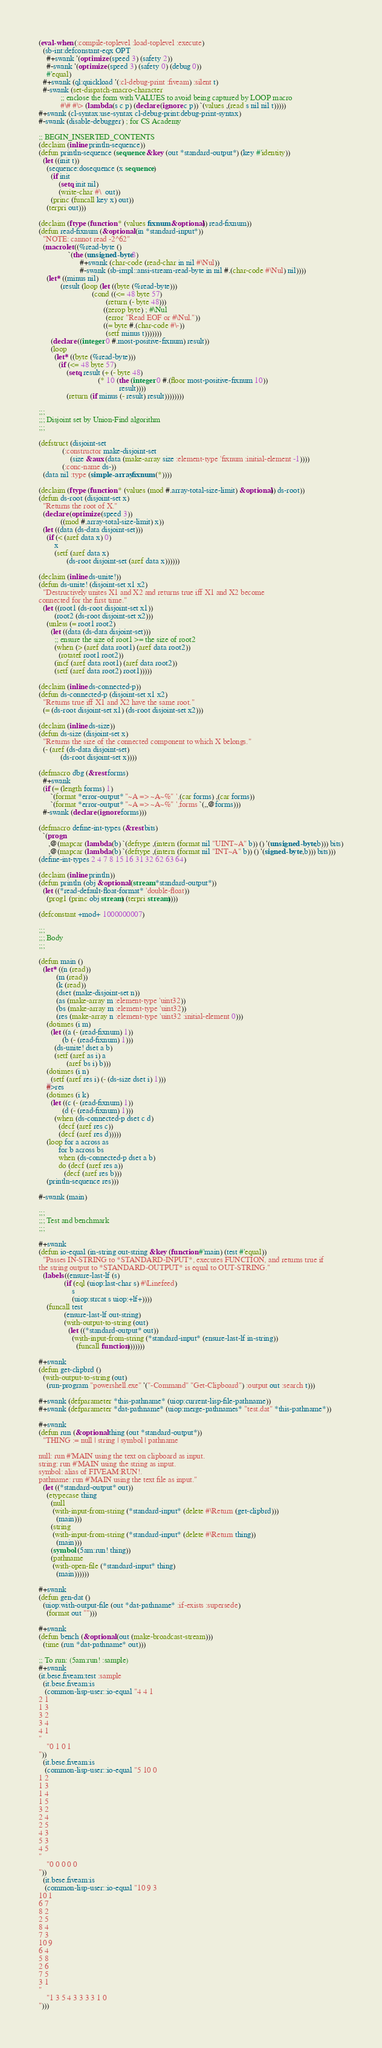<code> <loc_0><loc_0><loc_500><loc_500><_Lisp_>(eval-when (:compile-toplevel :load-toplevel :execute)
  (sb-int:defconstant-eqx OPT
    #+swank '(optimize (speed 3) (safety 2))
    #-swank '(optimize (speed 3) (safety 0) (debug 0))
    #'equal)
  #+swank (ql:quickload '(:cl-debug-print :fiveam) :silent t)
  #-swank (set-dispatch-macro-character
           ;; enclose the form with VALUES to avoid being captured by LOOP macro
           #\# #\> (lambda (s c p) (declare (ignore c p)) `(values ,(read s nil nil t)))))
#+swank (cl-syntax:use-syntax cl-debug-print:debug-print-syntax)
#-swank (disable-debugger) ; for CS Academy

;; BEGIN_INSERTED_CONTENTS
(declaim (inline println-sequence))
(defun println-sequence (sequence &key (out *standard-output*) (key #'identity))
  (let ((init t))
    (sequence:dosequence (x sequence)
      (if init
          (setq init nil)
          (write-char #\  out))
      (princ (funcall key x) out))
    (terpri out)))

(declaim (ftype (function * (values fixnum &optional)) read-fixnum))
(defun read-fixnum (&optional (in *standard-input*))
  "NOTE: cannot read -2^62"
  (macrolet ((%read-byte ()
               `(the (unsigned-byte 8)
                     #+swank (char-code (read-char in nil #\Nul))
                     #-swank (sb-impl::ansi-stream-read-byte in nil #.(char-code #\Nul) nil))))
    (let* ((minus nil)
           (result (loop (let ((byte (%read-byte)))
                           (cond ((<= 48 byte 57)
                                  (return (- byte 48)))
                                 ((zerop byte) ; #\Nul
                                  (error "Read EOF or #\Nul."))
                                 ((= byte #.(char-code #\-))
                                  (setf minus t)))))))
      (declare ((integer 0 #.most-positive-fixnum) result))
      (loop
        (let* ((byte (%read-byte)))
          (if (<= 48 byte 57)
              (setq result (+ (- byte 48)
                              (* 10 (the (integer 0 #.(floor most-positive-fixnum 10))
                                         result))))
              (return (if minus (- result) result))))))))

;;;
;;; Disjoint set by Union-Find algorithm
;;;

(defstruct (disjoint-set
            (:constructor make-disjoint-set
                (size &aux (data (make-array size :element-type 'fixnum :initial-element -1))))
            (:conc-name ds-))
  (data nil :type (simple-array fixnum (*))))

(declaim (ftype (function * (values (mod #.array-total-size-limit) &optional)) ds-root))
(defun ds-root (disjoint-set x)
  "Returns the root of X."
  (declare (optimize (speed 3))
           ((mod #.array-total-size-limit) x))
  (let ((data (ds-data disjoint-set)))
    (if (< (aref data x) 0)
        x
        (setf (aref data x)
              (ds-root disjoint-set (aref data x))))))

(declaim (inline ds-unite!))
(defun ds-unite! (disjoint-set x1 x2)
  "Destructively unites X1 and X2 and returns true iff X1 and X2 become
connected for the first time."
  (let ((root1 (ds-root disjoint-set x1))
        (root2 (ds-root disjoint-set x2)))
    (unless (= root1 root2)
      (let ((data (ds-data disjoint-set)))
        ;; ensure the size of root1 >= the size of root2
        (when (> (aref data root1) (aref data root2))
          (rotatef root1 root2))
        (incf (aref data root1) (aref data root2))
        (setf (aref data root2) root1)))))

(declaim (inline ds-connected-p))
(defun ds-connected-p (disjoint-set x1 x2)
  "Returns true iff X1 and X2 have the same root."
  (= (ds-root disjoint-set x1) (ds-root disjoint-set x2)))

(declaim (inline ds-size))
(defun ds-size (disjoint-set x)
  "Returns the size of the connected component to which X belongs."
  (- (aref (ds-data disjoint-set)
           (ds-root disjoint-set x))))

(defmacro dbg (&rest forms)
  #+swank
  (if (= (length forms) 1)
      `(format *error-output* "~A => ~A~%" ',(car forms) ,(car forms))
      `(format *error-output* "~A => ~A~%" ',forms `(,,@forms)))
  #-swank (declare (ignore forms)))

(defmacro define-int-types (&rest bits)
  `(progn
     ,@(mapcar (lambda (b) `(deftype ,(intern (format nil "UINT~A" b)) () '(unsigned-byte ,b))) bits)
     ,@(mapcar (lambda (b) `(deftype ,(intern (format nil "INT~A" b)) () '(signed-byte ,b))) bits)))
(define-int-types 2 4 7 8 15 16 31 32 62 63 64)

(declaim (inline println))
(defun println (obj &optional (stream *standard-output*))
  (let ((*read-default-float-format* 'double-float))
    (prog1 (princ obj stream) (terpri stream))))

(defconstant +mod+ 1000000007)

;;;
;;; Body
;;;

(defun main ()
  (let* ((n (read))
         (m (read))
         (k (read))
         (dset (make-disjoint-set n))
         (as (make-array m :element-type 'uint32))
         (bs (make-array m :element-type 'uint32))
         (res (make-array n :element-type 'uint32 :initial-element 0)))
    (dotimes (i m)
      (let ((a (- (read-fixnum) 1))
            (b (- (read-fixnum) 1)))
        (ds-unite! dset a b)
        (setf (aref as i) a
              (aref bs i) b)))
    (dotimes (i n)
      (setf (aref res i) (- (ds-size dset i) 1)))
    #>res
    (dotimes (i k)
      (let ((c (- (read-fixnum) 1))
            (d (- (read-fixnum) 1)))
        (when (ds-connected-p dset c d)
          (decf (aref res c))
          (decf (aref res d)))))
    (loop for a across as
          for b across bs
          when (ds-connected-p dset a b)
          do (decf (aref res a))
             (decf (aref res b)))
    (println-sequence res)))

#-swank (main)

;;;
;;; Test and benchmark
;;;

#+swank
(defun io-equal (in-string out-string &key (function #'main) (test #'equal))
  "Passes IN-STRING to *STANDARD-INPUT*, executes FUNCTION, and returns true if
the string output to *STANDARD-OUTPUT* is equal to OUT-STRING."
  (labels ((ensure-last-lf (s)
             (if (eql (uiop:last-char s) #\Linefeed)
                 s
                 (uiop:strcat s uiop:+lf+))))
    (funcall test
             (ensure-last-lf out-string)
             (with-output-to-string (out)
               (let ((*standard-output* out))
                 (with-input-from-string (*standard-input* (ensure-last-lf in-string))
                   (funcall function)))))))

#+swank
(defun get-clipbrd ()
  (with-output-to-string (out)
    (run-program "powershell.exe" '("-Command" "Get-Clipboard") :output out :search t)))

#+swank (defparameter *this-pathname* (uiop:current-lisp-file-pathname))
#+swank (defparameter *dat-pathname* (uiop:merge-pathnames* "test.dat" *this-pathname*))

#+swank
(defun run (&optional thing (out *standard-output*))
  "THING := null | string | symbol | pathname

null: run #'MAIN using the text on clipboard as input.
string: run #'MAIN using the string as input.
symbol: alias of FIVEAM:RUN!.
pathname: run #'MAIN using the text file as input."
  (let ((*standard-output* out))
    (etypecase thing
      (null
       (with-input-from-string (*standard-input* (delete #\Return (get-clipbrd)))
         (main)))
      (string
       (with-input-from-string (*standard-input* (delete #\Return thing))
         (main)))
      (symbol (5am:run! thing))
      (pathname
       (with-open-file (*standard-input* thing)
         (main))))))

#+swank
(defun gen-dat ()
  (uiop:with-output-file (out *dat-pathname* :if-exists :supersede)
    (format out "")))

#+swank
(defun bench (&optional (out (make-broadcast-stream)))
  (time (run *dat-pathname* out)))

;; To run: (5am:run! :sample)
#+swank
(it.bese.fiveam:test :sample
  (it.bese.fiveam:is
   (common-lisp-user::io-equal "4 4 1
2 1
1 3
3 2
3 4
4 1
"
    "0 1 0 1
"))
  (it.bese.fiveam:is
   (common-lisp-user::io-equal "5 10 0
1 2
1 3
1 4
1 5
3 2
2 4
2 5
4 3
5 3
4 5
"
    "0 0 0 0 0
"))
  (it.bese.fiveam:is
   (common-lisp-user::io-equal "10 9 3
10 1
6 7
8 2
2 5
8 4
7 3
10 9
6 4
5 8
2 6
7 5
3 1
"
    "1 3 5 4 3 3 3 3 1 0
")))
</code> 